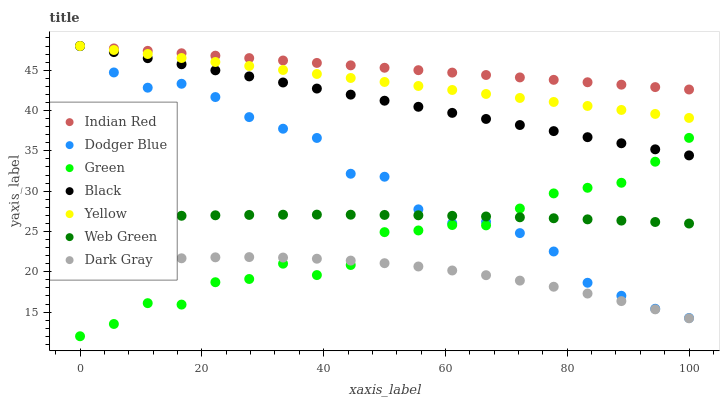Does Dark Gray have the minimum area under the curve?
Answer yes or no. Yes. Does Indian Red have the maximum area under the curve?
Answer yes or no. Yes. Does Web Green have the minimum area under the curve?
Answer yes or no. No. Does Web Green have the maximum area under the curve?
Answer yes or no. No. Is Yellow the smoothest?
Answer yes or no. Yes. Is Green the roughest?
Answer yes or no. Yes. Is Web Green the smoothest?
Answer yes or no. No. Is Web Green the roughest?
Answer yes or no. No. Does Green have the lowest value?
Answer yes or no. Yes. Does Web Green have the lowest value?
Answer yes or no. No. Does Indian Red have the highest value?
Answer yes or no. Yes. Does Web Green have the highest value?
Answer yes or no. No. Is Dodger Blue less than Black?
Answer yes or no. Yes. Is Dodger Blue greater than Dark Gray?
Answer yes or no. Yes. Does Green intersect Dodger Blue?
Answer yes or no. Yes. Is Green less than Dodger Blue?
Answer yes or no. No. Is Green greater than Dodger Blue?
Answer yes or no. No. Does Dodger Blue intersect Black?
Answer yes or no. No. 